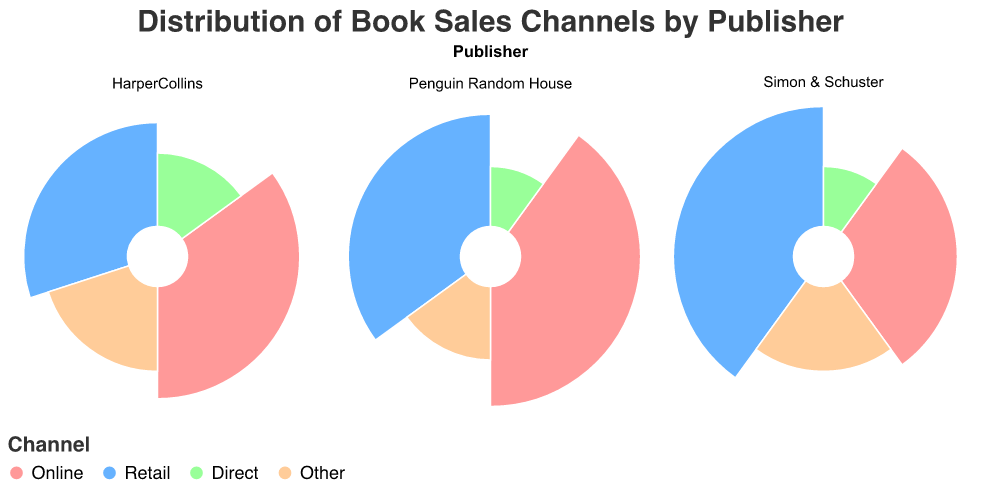How many publishers are included in the figure? By observing the titles of the polar charts, we notice that there are three publishers: HarperCollins, Penguin Random House, and Simon & Schuster.
Answer: 3 Which sales channel has the highest sales percentage for HarperCollins? By examining the arc sections of HarperCollins’ chart, we can see that Online (represented in pink) has the largest portion of the chart.
Answer: Online What is the combined sales percentage for the 'Retail' channel across all publishers? Add the Retail sales percentages: 30% (HarperCollins) + 35% (Penguin Random House) + 40% (Simon & Schuster), which equals 105%.
Answer: 105% Which publisher has the smallest percentage for the 'Direct' sales channel? By looking at the Direct sections in all polar charts, we see that Penguin Random House has the smallest arc, which represents 10%.
Answer: Penguin Random House Compare the 'Other' sales percentages for HarperCollins and Penguin Random House. Which is higher? HarperCollins has 20% and Penguin Random House has 15%, making HarperCollins higher.
Answer: HarperCollins Between Simon & Schuster and HarperCollins, which has a higher combined percentage for Online and Retail channels? HarperCollins: Online (35%) + Retail (30%) = 65%; Simon & Schuster: Online (30%) + Retail (40%) = 70%. Simon & Schuster has a higher total.
Answer: Simon & Schuster What is the difference in the sales percentage for the 'Online' channel between Penguin Random House and Simon & Schuster? The difference is 40% (Penguin Random House) - 30% (Simon & Schuster) = 10%.
Answer: 10% How is the 'Direct' sales percentage visually represented for each publisher? The 'Direct' channel is represented in light green arcs with HarperCollins at 15%, Penguin Random House at 10%, and Simon & Schuster also at 10%.
Answer: Light green arcs Considering all publishers, which sales channel has the most balanced distribution among them? The 'Direct' sales percentages are very close across all three publishers (HarperCollins: 15%, Penguin Random House: 10%, Simon & Schuster: 10%), suggesting a balanced distribution.
Answer: Direct Which publisher has the largest arc for the 'Retail' channel? By comparing the Retail arcs in all polar charts, Simon & Schuster has the largest arc at 40%.
Answer: Simon & Schuster 